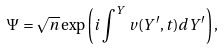Convert formula to latex. <formula><loc_0><loc_0><loc_500><loc_500>\Psi = \sqrt { n } \exp \left ( i \int ^ { Y } v ( Y ^ { \prime } , t ) d Y ^ { \prime } \right ) ,</formula> 